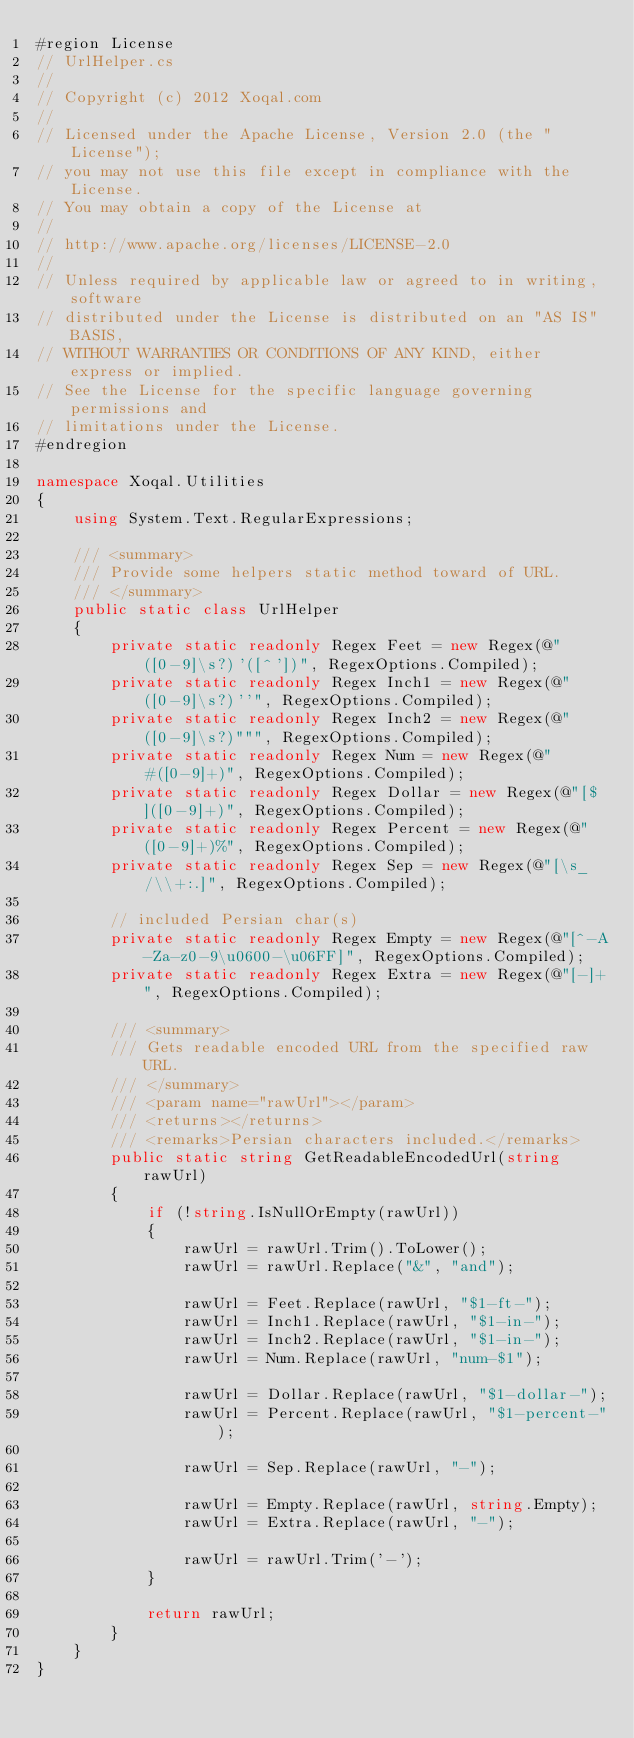<code> <loc_0><loc_0><loc_500><loc_500><_C#_>#region License
// UrlHelper.cs
// 
// Copyright (c) 2012 Xoqal.com
//
// Licensed under the Apache License, Version 2.0 (the "License");
// you may not use this file except in compliance with the License.
// You may obtain a copy of the License at
// 
// http://www.apache.org/licenses/LICENSE-2.0
// 
// Unless required by applicable law or agreed to in writing, software
// distributed under the License is distributed on an "AS IS" BASIS,
// WITHOUT WARRANTIES OR CONDITIONS OF ANY KIND, either express or implied.
// See the License for the specific language governing permissions and
// limitations under the License.
#endregion

namespace Xoqal.Utilities
{
    using System.Text.RegularExpressions;

    /// <summary>
    /// Provide some helpers static method toward of URL.
    /// </summary>
    public static class UrlHelper
    {
        private static readonly Regex Feet = new Regex(@"([0-9]\s?)'([^'])", RegexOptions.Compiled);
        private static readonly Regex Inch1 = new Regex(@"([0-9]\s?)''", RegexOptions.Compiled);
        private static readonly Regex Inch2 = new Regex(@"([0-9]\s?)""", RegexOptions.Compiled);
        private static readonly Regex Num = new Regex(@"#([0-9]+)", RegexOptions.Compiled);
        private static readonly Regex Dollar = new Regex(@"[$]([0-9]+)", RegexOptions.Compiled);
        private static readonly Regex Percent = new Regex(@"([0-9]+)%", RegexOptions.Compiled);
        private static readonly Regex Sep = new Regex(@"[\s_/\\+:.]", RegexOptions.Compiled);

        // included Persian char(s)
        private static readonly Regex Empty = new Regex(@"[^-A-Za-z0-9\u0600-\u06FF]", RegexOptions.Compiled);
        private static readonly Regex Extra = new Regex(@"[-]+", RegexOptions.Compiled);

        /// <summary>
        /// Gets readable encoded URL from the specified raw URL.
        /// </summary>
        /// <param name="rawUrl"></param>
        /// <returns></returns>
        /// <remarks>Persian characters included.</remarks>
        public static string GetReadableEncodedUrl(string rawUrl)
        {
            if (!string.IsNullOrEmpty(rawUrl))
            {
                rawUrl = rawUrl.Trim().ToLower();
                rawUrl = rawUrl.Replace("&", "and");

                rawUrl = Feet.Replace(rawUrl, "$1-ft-");
                rawUrl = Inch1.Replace(rawUrl, "$1-in-");
                rawUrl = Inch2.Replace(rawUrl, "$1-in-");
                rawUrl = Num.Replace(rawUrl, "num-$1");

                rawUrl = Dollar.Replace(rawUrl, "$1-dollar-");
                rawUrl = Percent.Replace(rawUrl, "$1-percent-");

                rawUrl = Sep.Replace(rawUrl, "-");

                rawUrl = Empty.Replace(rawUrl, string.Empty);
                rawUrl = Extra.Replace(rawUrl, "-");

                rawUrl = rawUrl.Trim('-');
            }

            return rawUrl;
        }
    }
}
</code> 